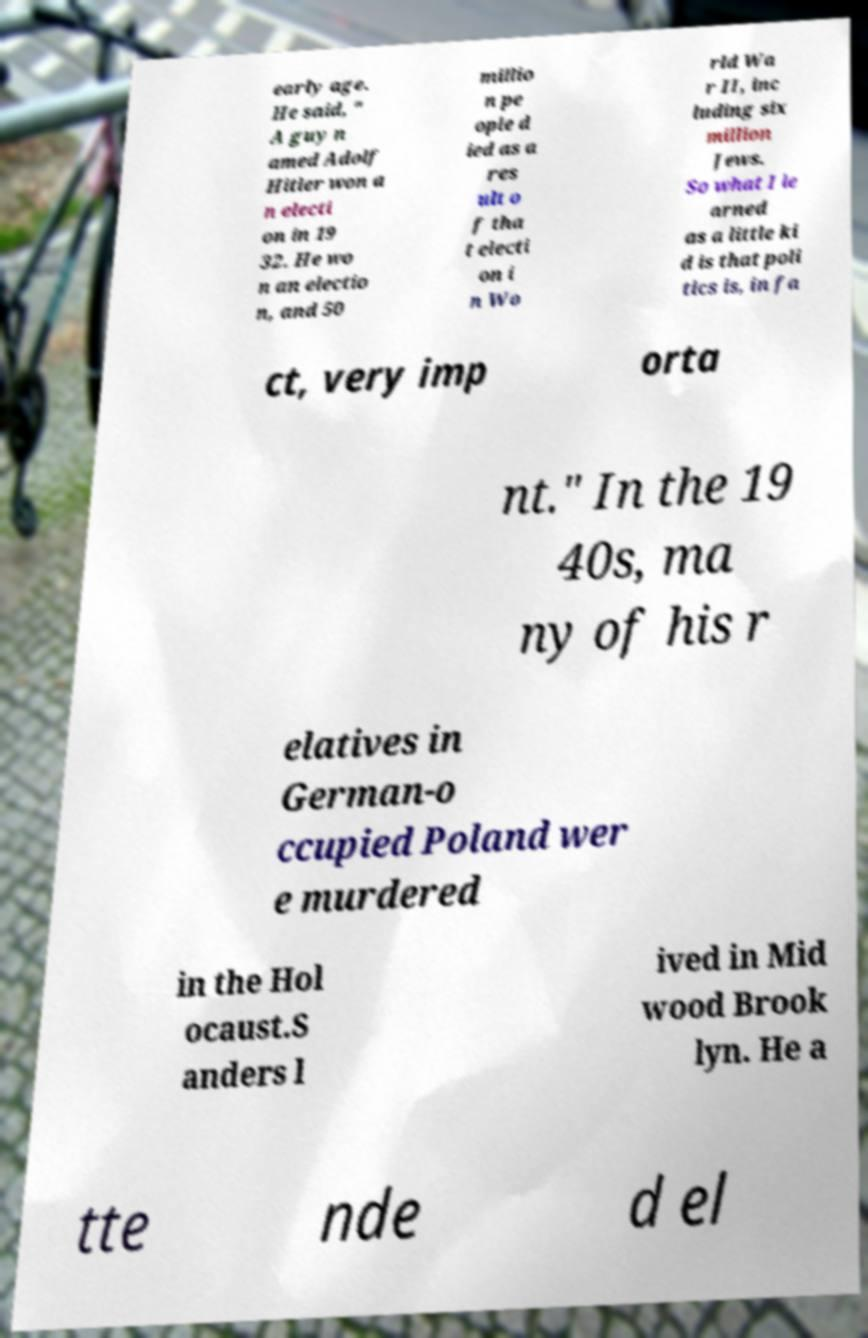Could you assist in decoding the text presented in this image and type it out clearly? early age. He said, " A guy n amed Adolf Hitler won a n electi on in 19 32. He wo n an electio n, and 50 millio n pe ople d ied as a res ult o f tha t electi on i n Wo rld Wa r II, inc luding six million Jews. So what I le arned as a little ki d is that poli tics is, in fa ct, very imp orta nt." In the 19 40s, ma ny of his r elatives in German-o ccupied Poland wer e murdered in the Hol ocaust.S anders l ived in Mid wood Brook lyn. He a tte nde d el 